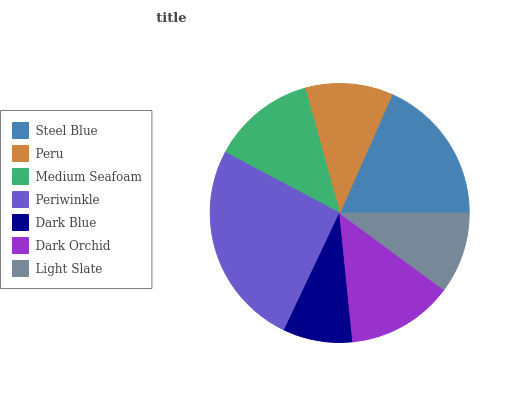Is Dark Blue the minimum?
Answer yes or no. Yes. Is Periwinkle the maximum?
Answer yes or no. Yes. Is Peru the minimum?
Answer yes or no. No. Is Peru the maximum?
Answer yes or no. No. Is Steel Blue greater than Peru?
Answer yes or no. Yes. Is Peru less than Steel Blue?
Answer yes or no. Yes. Is Peru greater than Steel Blue?
Answer yes or no. No. Is Steel Blue less than Peru?
Answer yes or no. No. Is Medium Seafoam the high median?
Answer yes or no. Yes. Is Medium Seafoam the low median?
Answer yes or no. Yes. Is Dark Orchid the high median?
Answer yes or no. No. Is Peru the low median?
Answer yes or no. No. 